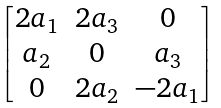Convert formula to latex. <formula><loc_0><loc_0><loc_500><loc_500>\begin{bmatrix} 2 a _ { 1 } & 2 a _ { 3 } & 0 \\ a _ { 2 } & 0 & a _ { 3 } \\ 0 & 2 a _ { 2 } & - 2 a _ { 1 } \end{bmatrix}</formula> 